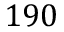<formula> <loc_0><loc_0><loc_500><loc_500>1 9 0</formula> 